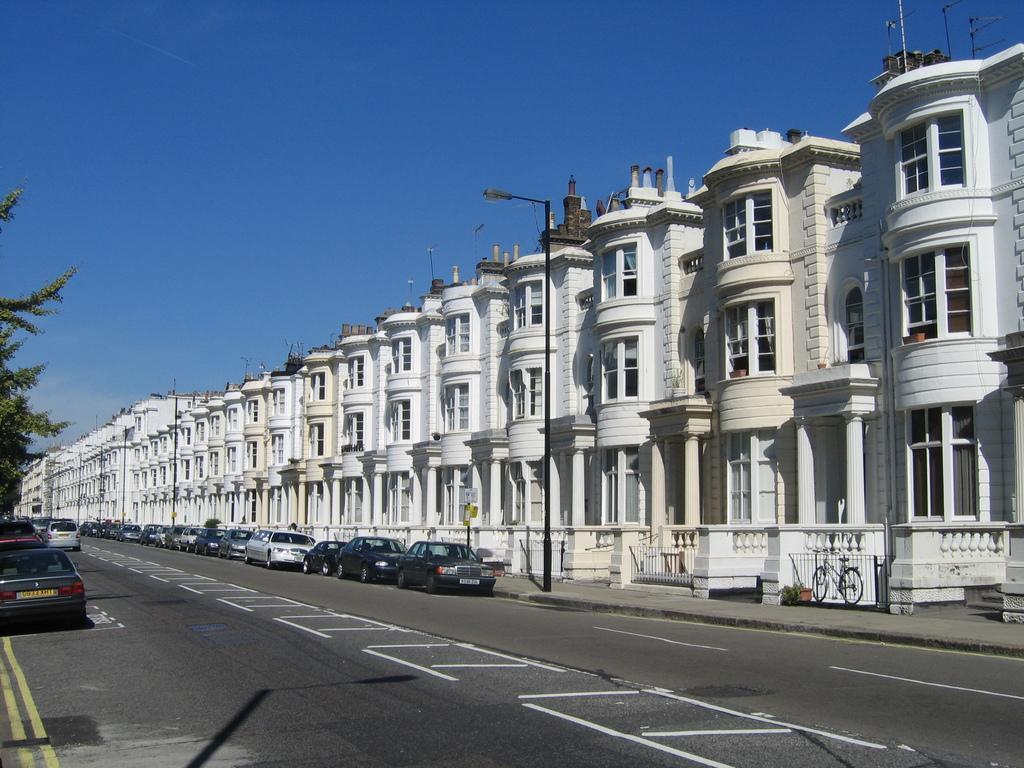Can you describe this image briefly? As we can see in the image there are buildings, street lamp, windows, vehicles, tree and sky. 